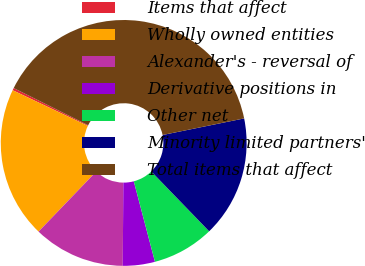Convert chart to OTSL. <chart><loc_0><loc_0><loc_500><loc_500><pie_chart><fcel>Items that affect<fcel>Wholly owned entities<fcel>Alexander's - reversal of<fcel>Derivative positions in<fcel>Other net<fcel>Minority limited partners'<fcel>Total items that affect<nl><fcel>0.31%<fcel>19.88%<fcel>12.05%<fcel>4.22%<fcel>8.14%<fcel>15.96%<fcel>39.44%<nl></chart> 